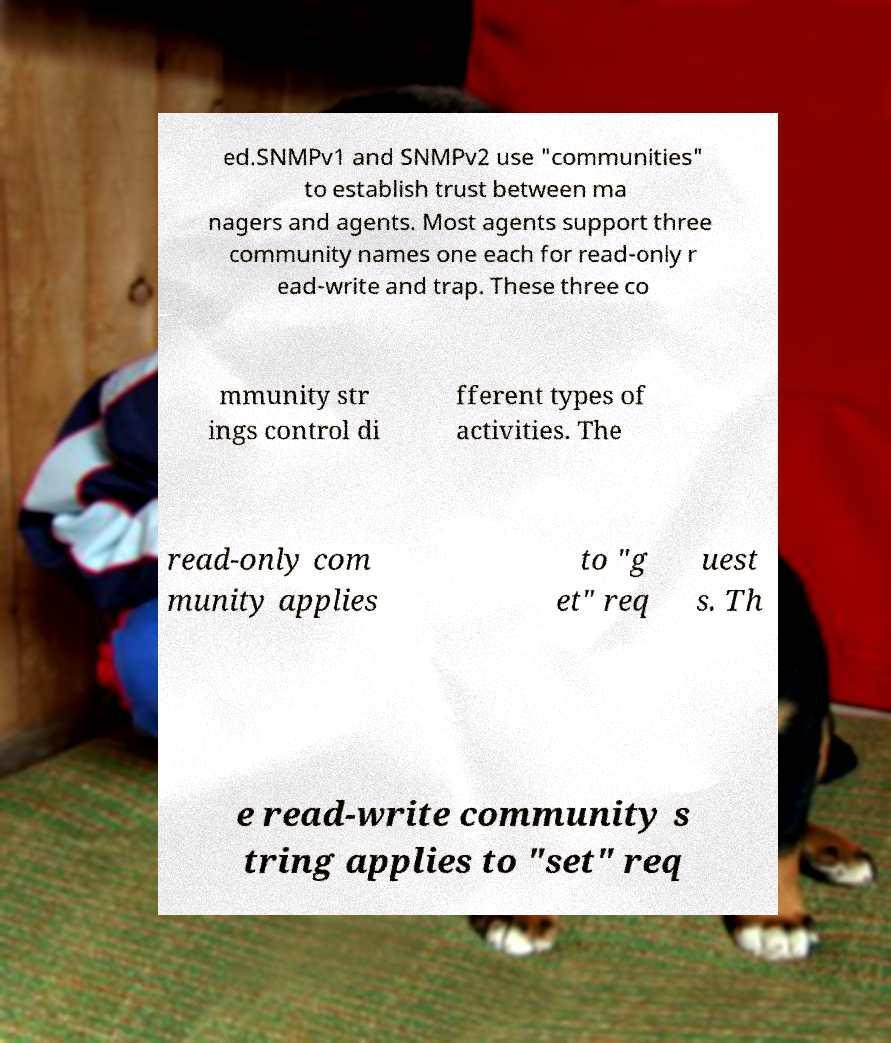Please read and relay the text visible in this image. What does it say? ed.SNMPv1 and SNMPv2 use "communities" to establish trust between ma nagers and agents. Most agents support three community names one each for read-only r ead-write and trap. These three co mmunity str ings control di fferent types of activities. The read-only com munity applies to "g et" req uest s. Th e read-write community s tring applies to "set" req 